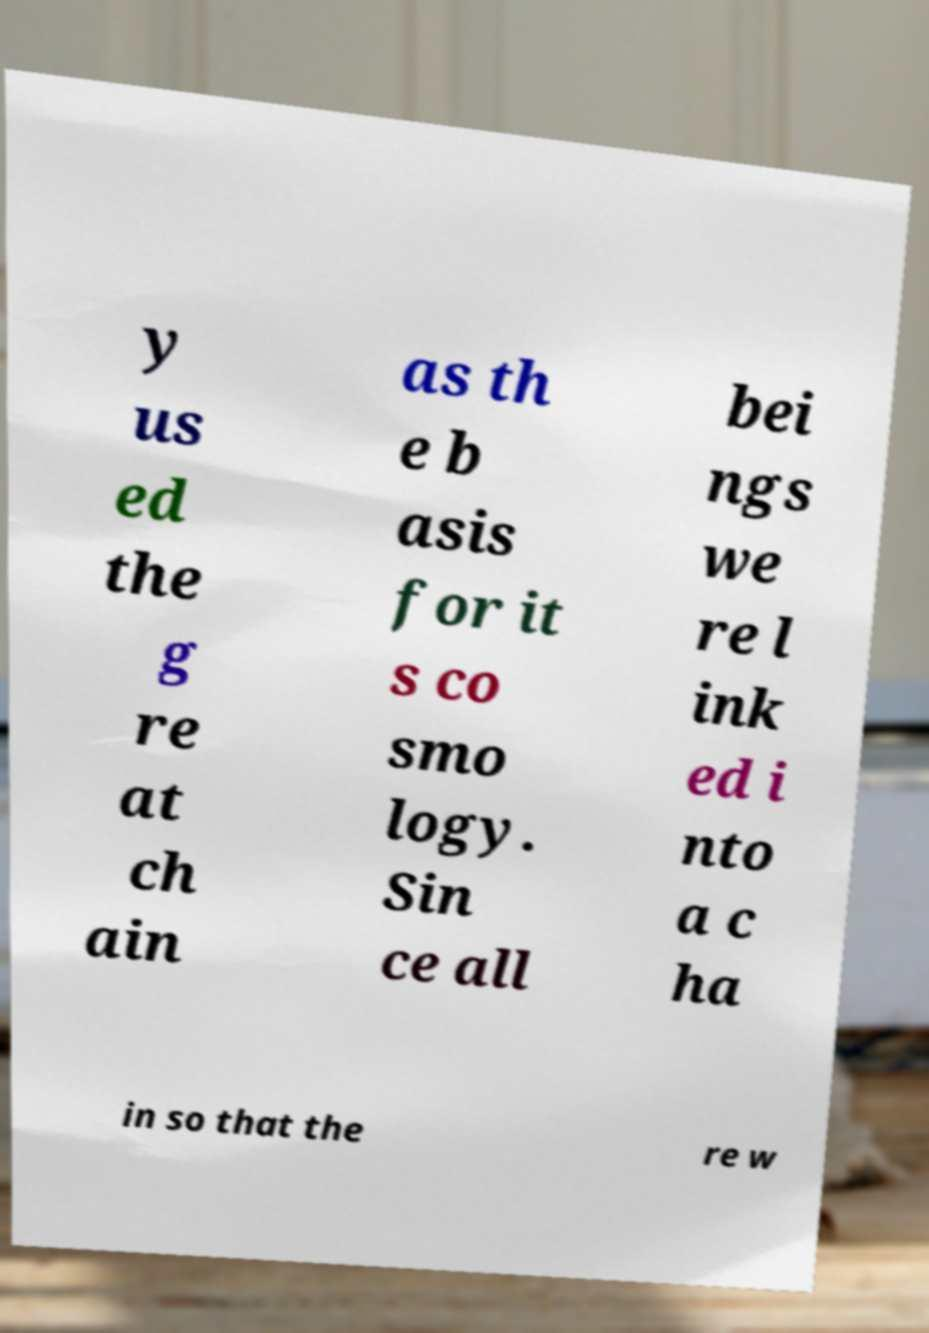Can you accurately transcribe the text from the provided image for me? y us ed the g re at ch ain as th e b asis for it s co smo logy. Sin ce all bei ngs we re l ink ed i nto a c ha in so that the re w 